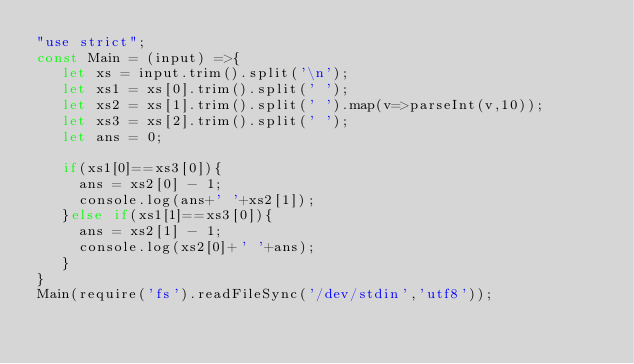<code> <loc_0><loc_0><loc_500><loc_500><_JavaScript_>"use strict";
const Main = (input) =>{
   let xs = input.trim().split('\n');
   let xs1 = xs[0].trim().split(' ');
   let xs2 = xs[1].trim().split(' ').map(v=>parseInt(v,10));
   let xs3 = xs[2].trim().split(' ');
   let ans = 0;
   
   if(xs1[0]==xs3[0]){
     ans = xs2[0] - 1;
     console.log(ans+' '+xs2[1]);
   }else if(xs1[1]==xs3[0]){
     ans = xs2[1] - 1;
     console.log(xs2[0]+' '+ans);
   }
}
Main(require('fs').readFileSync('/dev/stdin','utf8'));</code> 